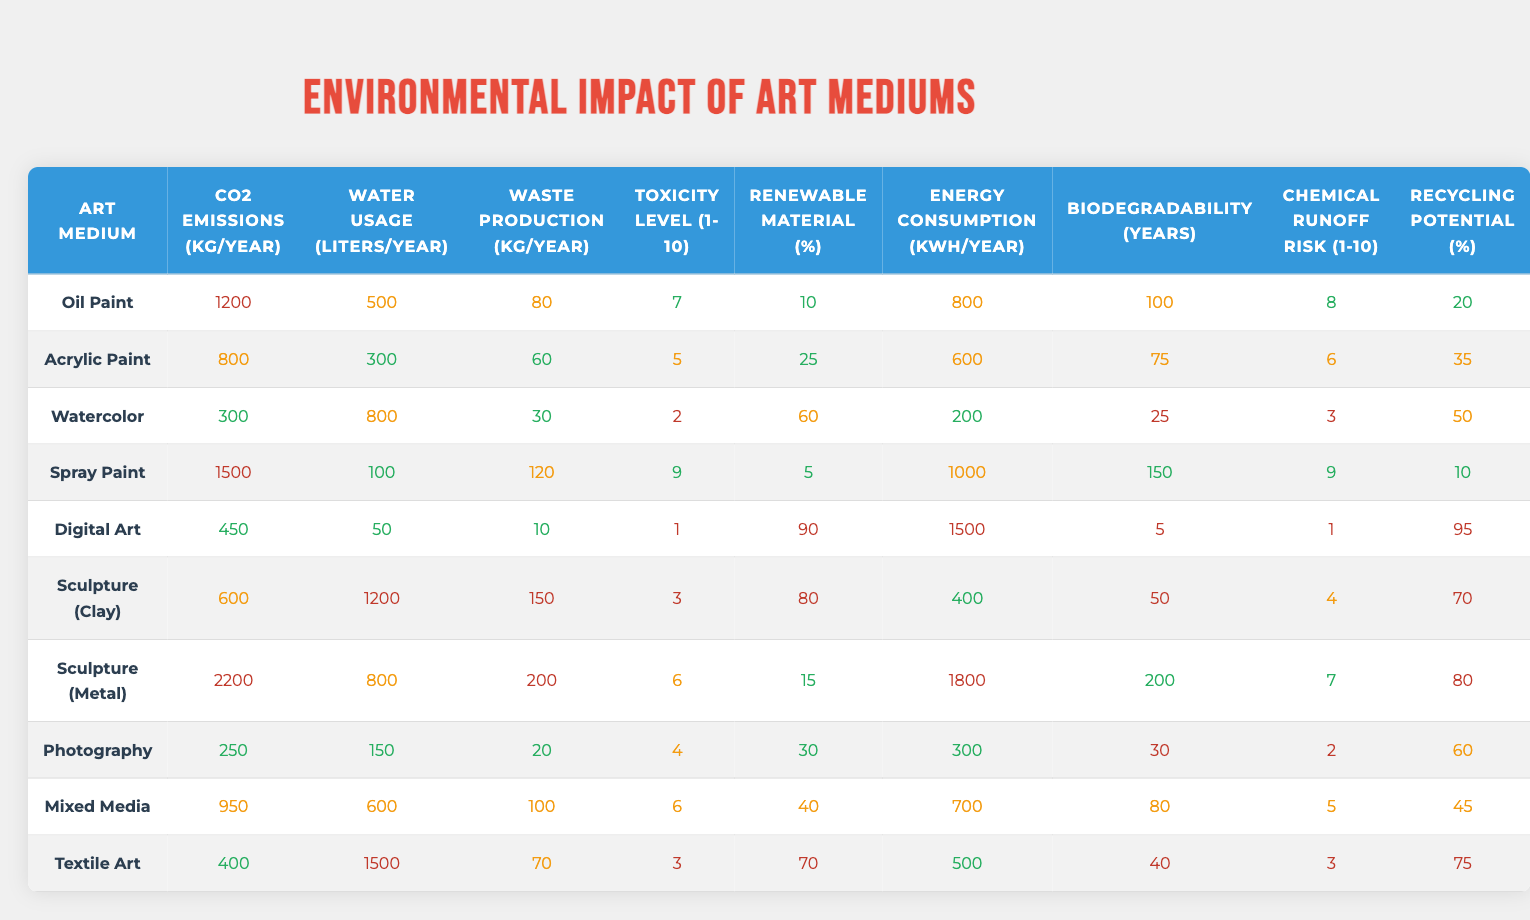What is the CO2 emission of Acrylic Paint? Referring to the table, the CO2 emissions for Acrylic Paint are listed as 800 kg/year.
Answer: 800 kg/year Which art medium has the highest water usage? By examining the water usage column, Sculpture (Clay) shows the highest water usage at 1200 liters/year.
Answer: Sculpture (Clay) What is the average waste production for Oil Paint and Spray Paint? The waste production for Oil Paint is 80 kg/year and for Spray Paint is 120 kg/year. The average is (80 + 120) / 2 = 100 kg/year.
Answer: 100 kg/year Is the recycling potential of Digital Art greater than 70%? The recycling potential for Digital Art is 95%. Since 95% is greater than 70%, the answer is yes.
Answer: Yes How much more CO2 is emitted from Sculpture (Metal) compared to Watercolor? Sculpture (Metal) emits 2200 kg/year, and Watercolor emits 300 kg/year. The difference is 2200 - 300 = 1900 kg/year.
Answer: 1900 kg/year What is the total energy consumption of all art mediums? Summing the energy consumption values: 800 + 600 + 200 + 1000 + 1500 + 400 + 1800 + 300 + 700 + 500 = 5900 kWh/year.
Answer: 5900 kWh/year Which art medium has the lowest toxicity level? Checking the toxicity levels, Watercolor has the lowest toxicity level at 2 on a 1-10 scale.
Answer: Watercolor Is the Renewable Material Percentage of Textile Art greater than that of Oil Paint? Textile Art has a Renewable Material Percentage of 70%, and Oil Paint has 10%. Since 70% is greater than 10%, the answer is yes.
Answer: Yes What is the combined biodegradable lifespan of Sculpture (Metal) and Acrylic Paint? Sculpture (Metal) has a biodegradability of 200 years and Acrylic Paint has 75 years. Combined, that is 200 + 75 = 275 years.
Answer: 275 years Which two art mediums have the highest chemical runoff risk? Sculpture (Metal) has a chemical runoff risk of 7, and Spray Paint has a risk of 9. Both are significant, but Spray Paint has the highest.
Answer: Spray Paint and Sculpture (Metal) 